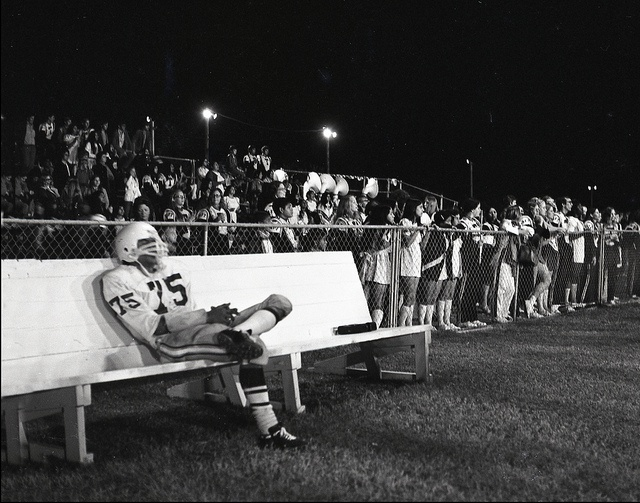Describe the objects in this image and their specific colors. I can see people in black, gray, darkgray, and lightgray tones, bench in black, lightgray, darkgray, and gray tones, people in black, darkgray, lightgray, and gray tones, people in black, gray, darkgray, and lightgray tones, and people in black, lightgray, gray, and darkgray tones in this image. 